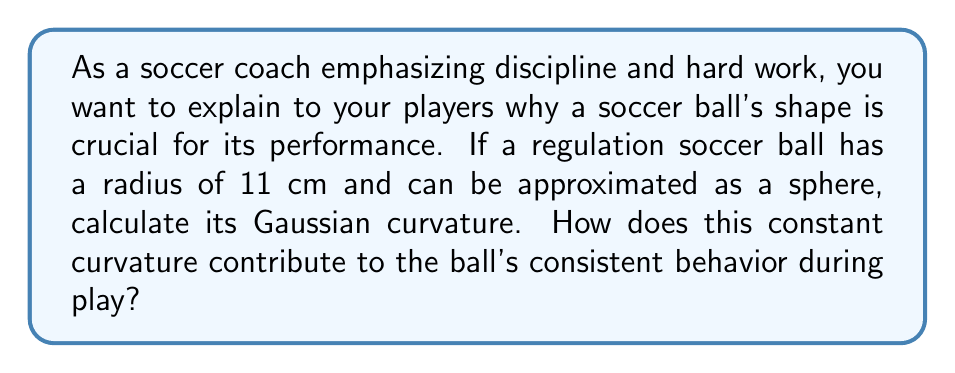What is the answer to this math problem? Let's approach this step-by-step:

1) The Gaussian curvature of a sphere is constant at every point on its surface. For a sphere, the Gaussian curvature $K$ is given by:

   $$K = \frac{1}{R^2}$$

   where $R$ is the radius of the sphere.

2) We are given that the radius of the soccer ball is 11 cm. Let's substitute this into our formula:

   $$K = \frac{1}{(11 \text{ cm})^2}$$

3) Simplify:

   $$K = \frac{1}{121 \text{ cm}^2}$$

4) This gives us the Gaussian curvature in units of cm^(-2).

5) To understand why this constant curvature is important:
   - A constant curvature means the ball's surface behaves the same way no matter where it's struck.
   - This consistency allows players to predict the ball's behavior, improving their control and accuracy.
   - The positive curvature gives the ball its rounded shape, which is crucial for its rolling and bouncing characteristics.
   - The specific value of the curvature affects how the ball interacts with air, influencing its flight path.
Answer: $\frac{1}{121} \text{ cm}^{-2}$ 